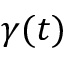Convert formula to latex. <formula><loc_0><loc_0><loc_500><loc_500>\gamma ( t )</formula> 